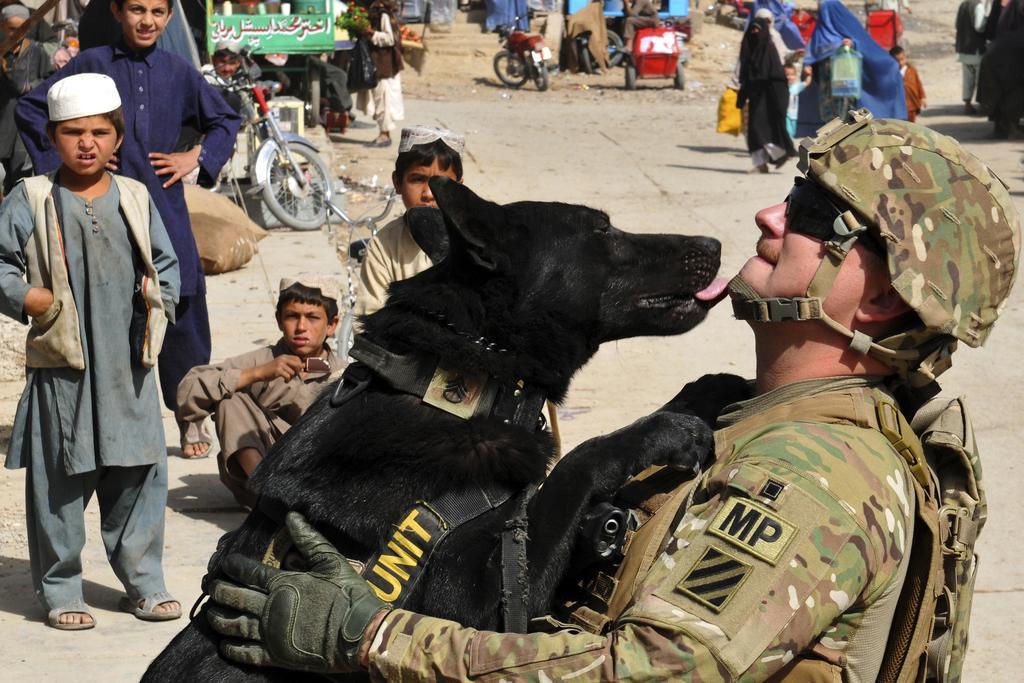Please provide a concise description of this image. Here in this picture in the front we can see a person in a military dress and holding a black colored dog present in front of him and we can see he is wearing gloves and goggles and helmet on him and beside him we can see children sitting and standing on the road and watching him and we can see motor cycles and trolleys here and there and we can see other people walking on the road over there. 